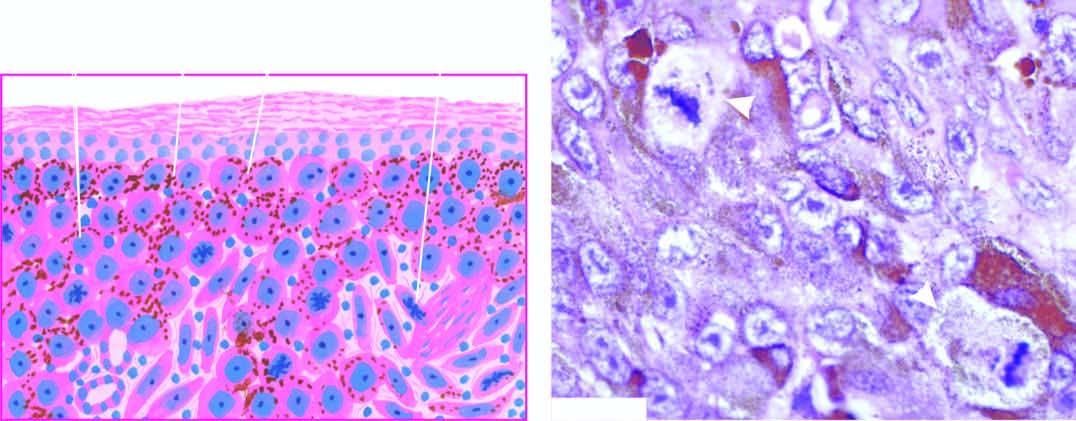does the portal tract show junctional activity at the dermal-epidermal junction?
Answer the question using a single word or phrase. No 